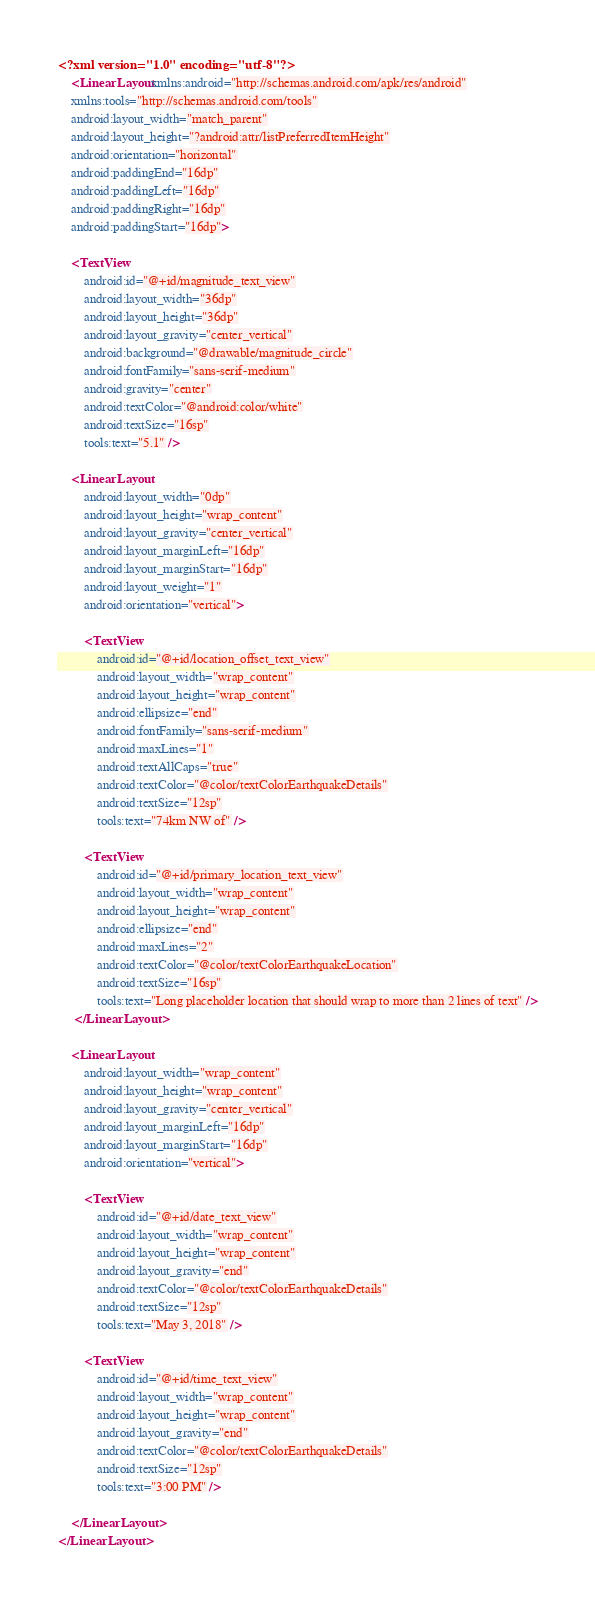Convert code to text. <code><loc_0><loc_0><loc_500><loc_500><_XML_><?xml version="1.0" encoding="utf-8"?>
    <LinearLayout xmlns:android="http://schemas.android.com/apk/res/android"
    xmlns:tools="http://schemas.android.com/tools"
    android:layout_width="match_parent"
    android:layout_height="?android:attr/listPreferredItemHeight"
    android:orientation="horizontal"
    android:paddingEnd="16dp"
    android:paddingLeft="16dp"
    android:paddingRight="16dp"
    android:paddingStart="16dp">

    <TextView
        android:id="@+id/magnitude_text_view"
        android:layout_width="36dp"
        android:layout_height="36dp"
        android:layout_gravity="center_vertical"
        android:background="@drawable/magnitude_circle"
        android:fontFamily="sans-serif-medium"
        android:gravity="center"
        android:textColor="@android:color/white"
        android:textSize="16sp"
        tools:text="5.1" />

    <LinearLayout
        android:layout_width="0dp"
        android:layout_height="wrap_content"
        android:layout_gravity="center_vertical"
        android:layout_marginLeft="16dp"
        android:layout_marginStart="16dp"
        android:layout_weight="1"
        android:orientation="vertical">

        <TextView
            android:id="@+id/location_offset_text_view"
            android:layout_width="wrap_content"
            android:layout_height="wrap_content"
            android:ellipsize="end"
            android:fontFamily="sans-serif-medium"
            android:maxLines="1"
            android:textAllCaps="true"
            android:textColor="@color/textColorEarthquakeDetails"
            android:textSize="12sp"
            tools:text="74km NW of" />

        <TextView
            android:id="@+id/primary_location_text_view"
            android:layout_width="wrap_content"
            android:layout_height="wrap_content"
            android:ellipsize="end"
            android:maxLines="2"
            android:textColor="@color/textColorEarthquakeLocation"
            android:textSize="16sp"
            tools:text="Long placeholder location that should wrap to more than 2 lines of text" />
     </LinearLayout>

    <LinearLayout
        android:layout_width="wrap_content"
        android:layout_height="wrap_content"
        android:layout_gravity="center_vertical"
        android:layout_marginLeft="16dp"
        android:layout_marginStart="16dp"
        android:orientation="vertical">

        <TextView
            android:id="@+id/date_text_view"
            android:layout_width="wrap_content"
            android:layout_height="wrap_content"
            android:layout_gravity="end"
            android:textColor="@color/textColorEarthquakeDetails"
            android:textSize="12sp"
            tools:text="May 3, 2018" />

        <TextView
            android:id="@+id/time_text_view"
            android:layout_width="wrap_content"
            android:layout_height="wrap_content"
            android:layout_gravity="end"
            android:textColor="@color/textColorEarthquakeDetails"
            android:textSize="12sp"
            tools:text="3:00 PM" />

    </LinearLayout>
</LinearLayout></code> 